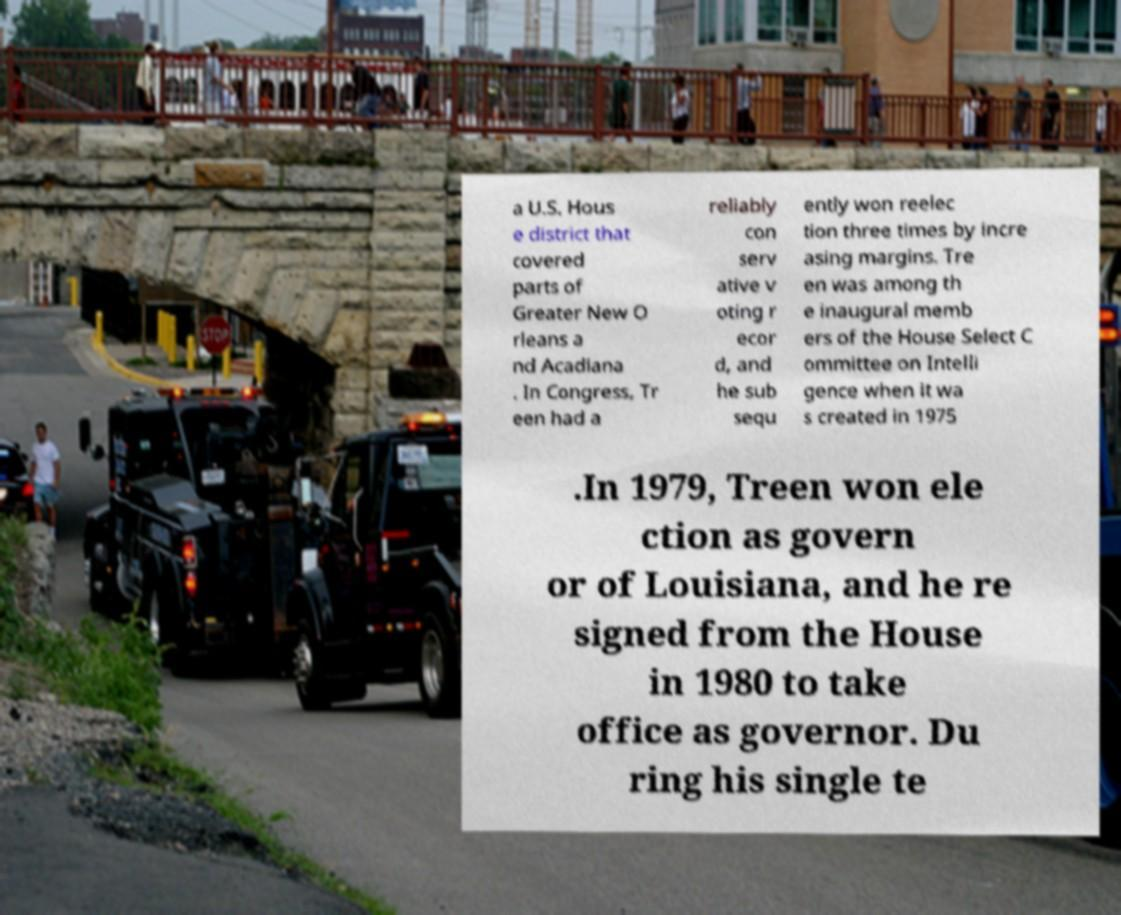There's text embedded in this image that I need extracted. Can you transcribe it verbatim? a U.S. Hous e district that covered parts of Greater New O rleans a nd Acadiana . In Congress, Tr een had a reliably con serv ative v oting r ecor d, and he sub sequ ently won reelec tion three times by incre asing margins. Tre en was among th e inaugural memb ers of the House Select C ommittee on Intelli gence when it wa s created in 1975 .In 1979, Treen won ele ction as govern or of Louisiana, and he re signed from the House in 1980 to take office as governor. Du ring his single te 